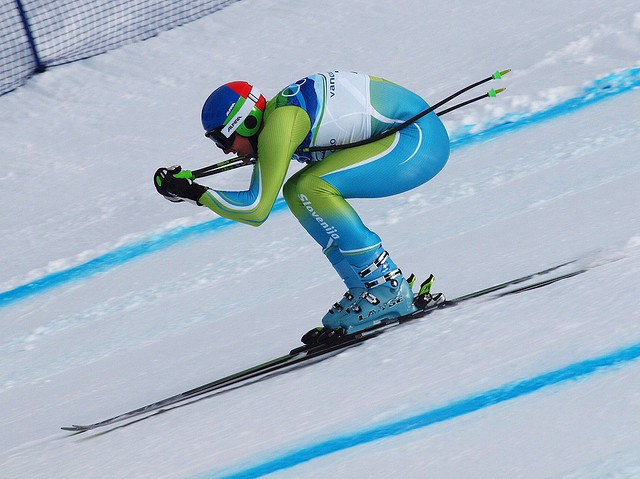Describe the objects in this image and their specific colors. I can see people in darkgray, teal, black, and lavender tones, skis in darkgray and lightgray tones, and skis in darkgray, black, gray, and blue tones in this image. 